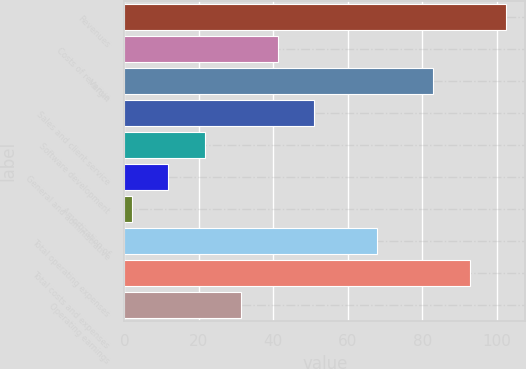Convert chart to OTSL. <chart><loc_0><loc_0><loc_500><loc_500><bar_chart><fcel>Revenues<fcel>Costs of revenue<fcel>Margin<fcel>Sales and client service<fcel>Software development<fcel>General and administrative<fcel>Amortization of<fcel>Total operating expenses<fcel>Total costs and expenses<fcel>Operating earnings<nl><fcel>102.6<fcel>41.2<fcel>83<fcel>51<fcel>21.6<fcel>11.8<fcel>2<fcel>68<fcel>92.8<fcel>31.4<nl></chart> 